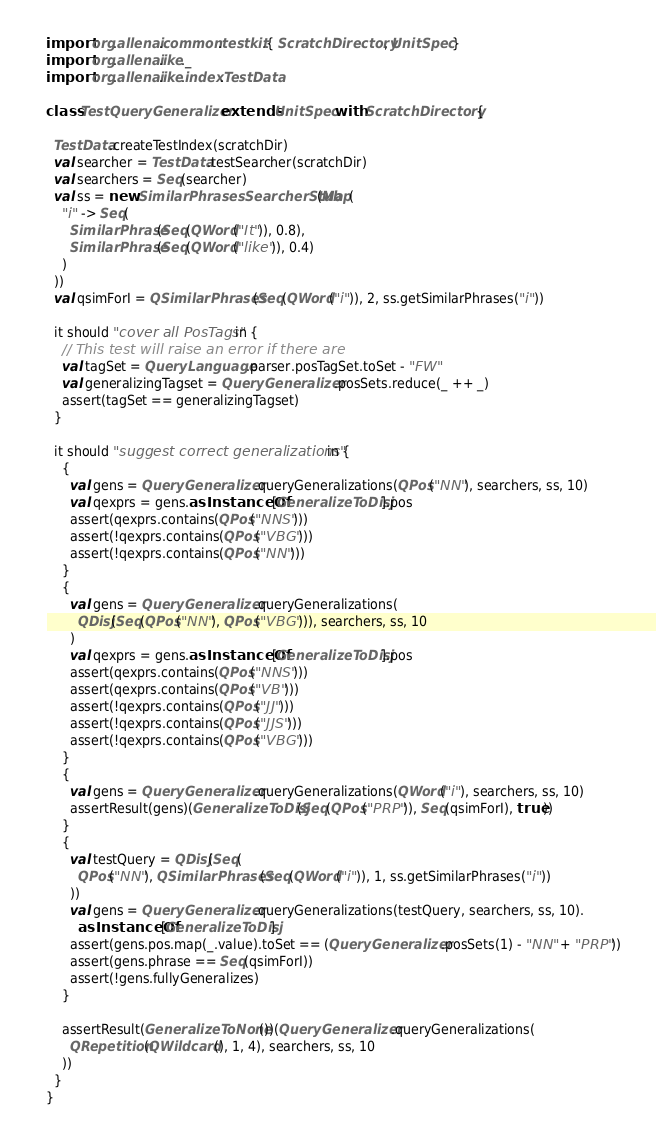Convert code to text. <code><loc_0><loc_0><loc_500><loc_500><_Scala_>
import org.allenai.common.testkit.{ ScratchDirectory, UnitSpec }
import org.allenai.ike._
import org.allenai.ike.index.TestData

class TestQueryGeneralizer extends UnitSpec with ScratchDirectory {

  TestData.createTestIndex(scratchDir)
  val searcher = TestData.testSearcher(scratchDir)
  val searchers = Seq(searcher)
  val ss = new SimilarPhrasesSearcherStub(Map(
    "i" -> Seq(
      SimilarPhrase(Seq(QWord("It")), 0.8),
      SimilarPhrase(Seq(QWord("like")), 0.4)
    )
  ))
  val qsimForI = QSimilarPhrases(Seq(QWord("i")), 2, ss.getSimilarPhrases("i"))

  it should "cover all PosTags" in {
    // This test will raise an error if there are
    val tagSet = QueryLanguage.parser.posTagSet.toSet - "FW"
    val generalizingTagset = QueryGeneralizer.posSets.reduce(_ ++ _)
    assert(tagSet == generalizingTagset)
  }

  it should "suggest correct generalizations" in {
    {
      val gens = QueryGeneralizer.queryGeneralizations(QPos("NN"), searchers, ss, 10)
      val qexprs = gens.asInstanceOf[GeneralizeToDisj].pos
      assert(qexprs.contains(QPos("NNS")))
      assert(!qexprs.contains(QPos("VBG")))
      assert(!qexprs.contains(QPos("NN")))
    }
    {
      val gens = QueryGeneralizer.queryGeneralizations(
        QDisj(Seq(QPos("NN"), QPos("VBG"))), searchers, ss, 10
      )
      val qexprs = gens.asInstanceOf[GeneralizeToDisj].pos
      assert(qexprs.contains(QPos("NNS")))
      assert(qexprs.contains(QPos("VB")))
      assert(!qexprs.contains(QPos("JJ")))
      assert(!qexprs.contains(QPos("JJS")))
      assert(!qexprs.contains(QPos("VBG")))
    }
    {
      val gens = QueryGeneralizer.queryGeneralizations(QWord("i"), searchers, ss, 10)
      assertResult(gens)(GeneralizeToDisj(Seq(QPos("PRP")), Seq(qsimForI), true))
    }
    {
      val testQuery = QDisj(Seq(
        QPos("NN"), QSimilarPhrases(Seq(QWord("i")), 1, ss.getSimilarPhrases("i"))
      ))
      val gens = QueryGeneralizer.queryGeneralizations(testQuery, searchers, ss, 10).
        asInstanceOf[GeneralizeToDisj]
      assert(gens.pos.map(_.value).toSet == (QueryGeneralizer.posSets(1) - "NN" + "PRP"))
      assert(gens.phrase == Seq(qsimForI))
      assert(!gens.fullyGeneralizes)
    }

    assertResult(GeneralizeToNone())(QueryGeneralizer.queryGeneralizations(
      QRepetition(QWildcard(), 1, 4), searchers, ss, 10
    ))
  }
}
</code> 